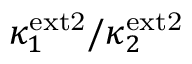Convert formula to latex. <formula><loc_0><loc_0><loc_500><loc_500>\kappa _ { 1 } ^ { e x t 2 } / \kappa _ { 2 } ^ { e x t 2 }</formula> 